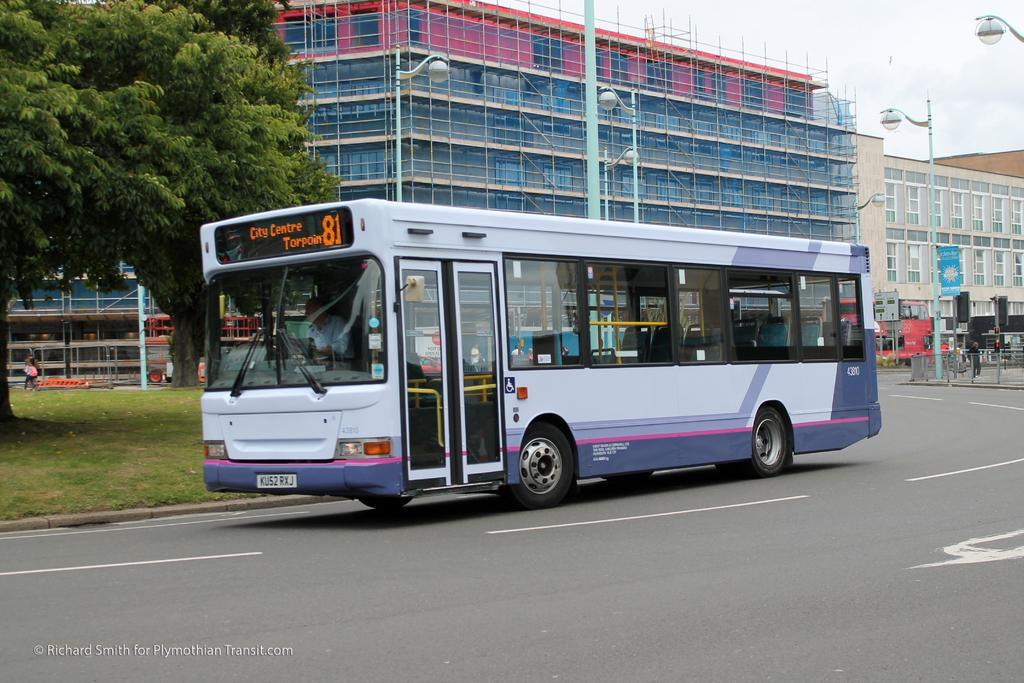<image>
Relay a brief, clear account of the picture shown. The number 81 bus driving down the road 